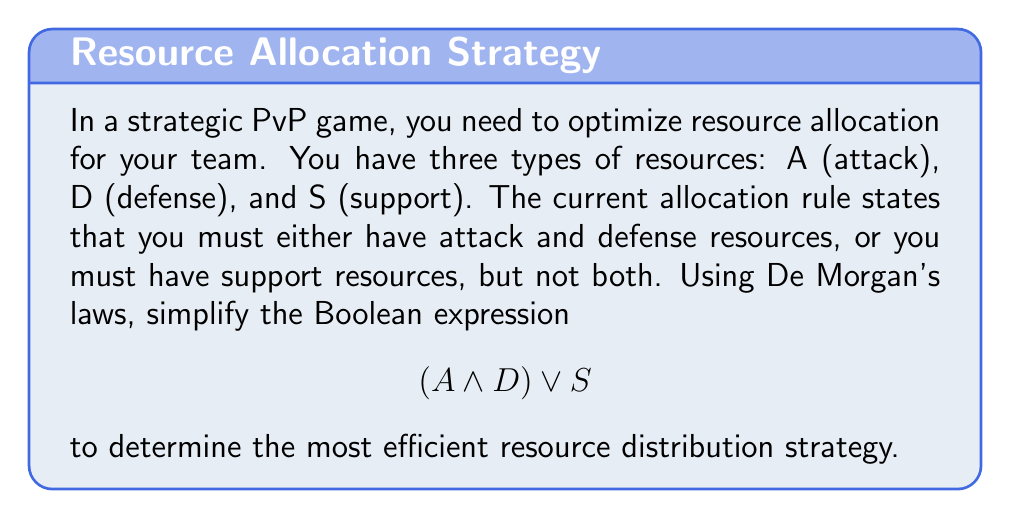Solve this math problem. To optimize the resource allocation strategy, we'll apply De Morgan's laws to simplify the given Boolean expression. Let's proceed step-by-step:

1. Start with the given expression:
   $$(A \land D) \lor S$$

2. Apply De Morgan's first law to the negation of this expression:
   $$\lnot((A \land D) \lor S)$$

3. According to De Morgan's first law, the negation of an OR operation becomes an AND operation of the negations:
   $$(\lnot(A \land D)) \land (\lnot S)$$

4. Now, apply De Morgan's second law to $\lnot(A \land D)$:
   $$(\lnot A \lor \lnot D) \land (\lnot S)$$

5. The expression is now in its simplified negated form. To get back to the original (non-negated) form, we need to apply negation to both sides:
   $$\lnot((\lnot A \lor \lnot D) \land (\lnot S))$$

6. Apply De Morgan's first law again:
   $$\lnot(\lnot A \lor \lnot D) \lor \lnot(\lnot S)$$

7. The double negation $\lnot(\lnot S)$ simplifies to $S$:
   $$\lnot(\lnot A \lor \lnot D) \lor S$$

8. Apply De Morgan's second law to $\lnot(\lnot A \lor \lnot D)$:
   $$(A \land D) \lor S$$

This final form is equivalent to the original expression, demonstrating that the original allocation rule was already in its most simplified form.
Answer: $(A \land D) \lor S$ 